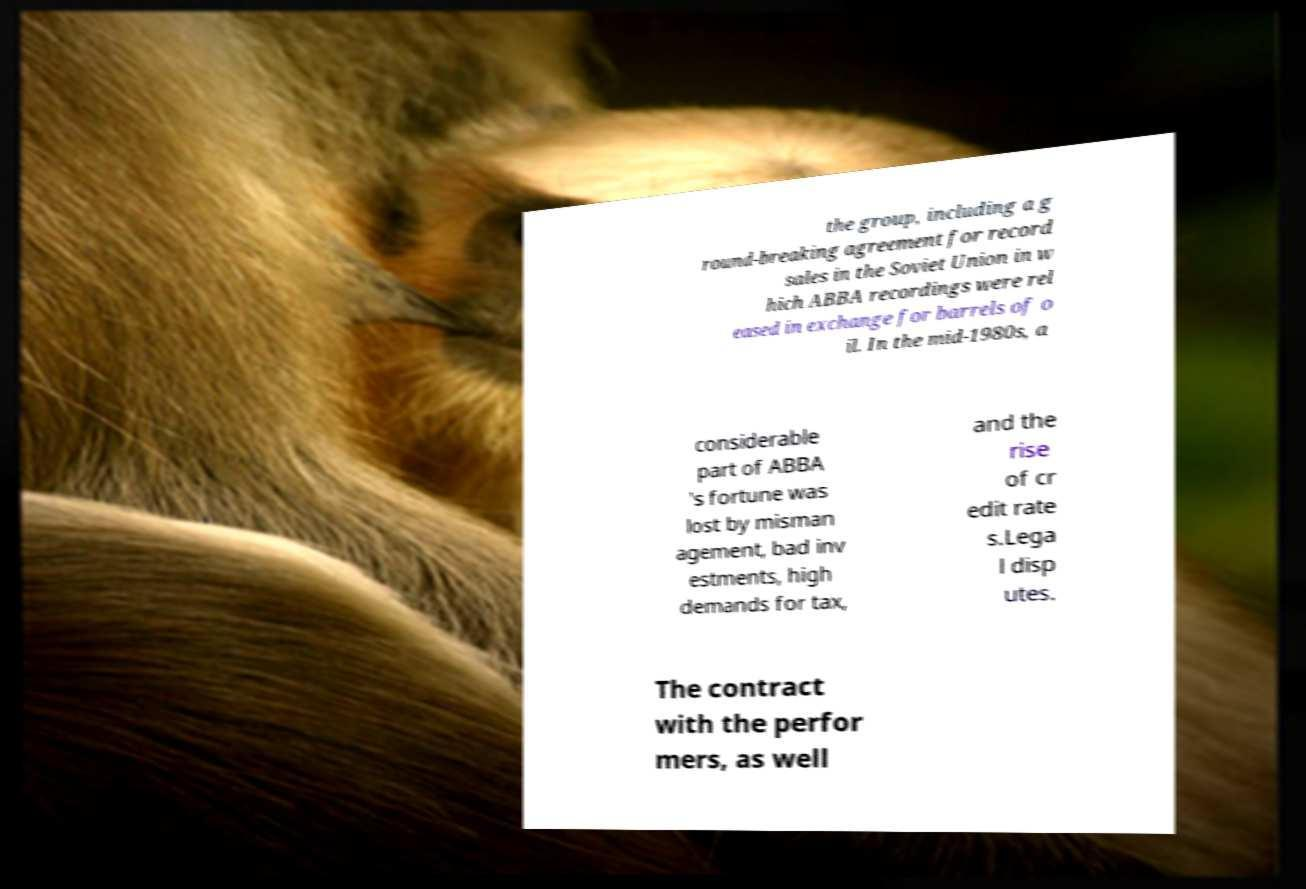Can you read and provide the text displayed in the image?This photo seems to have some interesting text. Can you extract and type it out for me? the group, including a g round-breaking agreement for record sales in the Soviet Union in w hich ABBA recordings were rel eased in exchange for barrels of o il. In the mid-1980s, a considerable part of ABBA 's fortune was lost by misman agement, bad inv estments, high demands for tax, and the rise of cr edit rate s.Lega l disp utes. The contract with the perfor mers, as well 